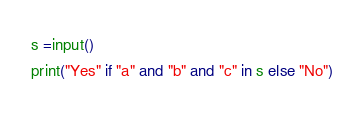<code> <loc_0><loc_0><loc_500><loc_500><_Python_>s =input()
print("Yes" if "a" and "b" and "c" in s else "No")</code> 